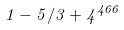<formula> <loc_0><loc_0><loc_500><loc_500>1 - 5 / 3 + 4 ^ { 4 6 6 }</formula> 